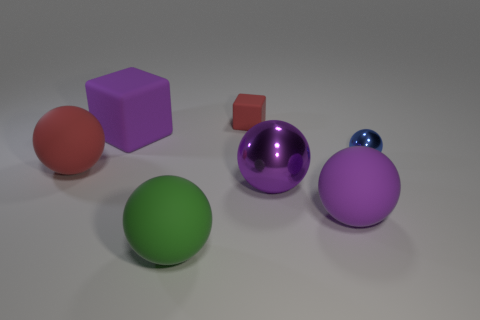What is the color of the tiny thing that is the same shape as the big red rubber object? The small object that shares its spherical shape with the large red rubber ball is colored blue. It's interesting to note the contrast in size and color between these two similarly shaped items. 